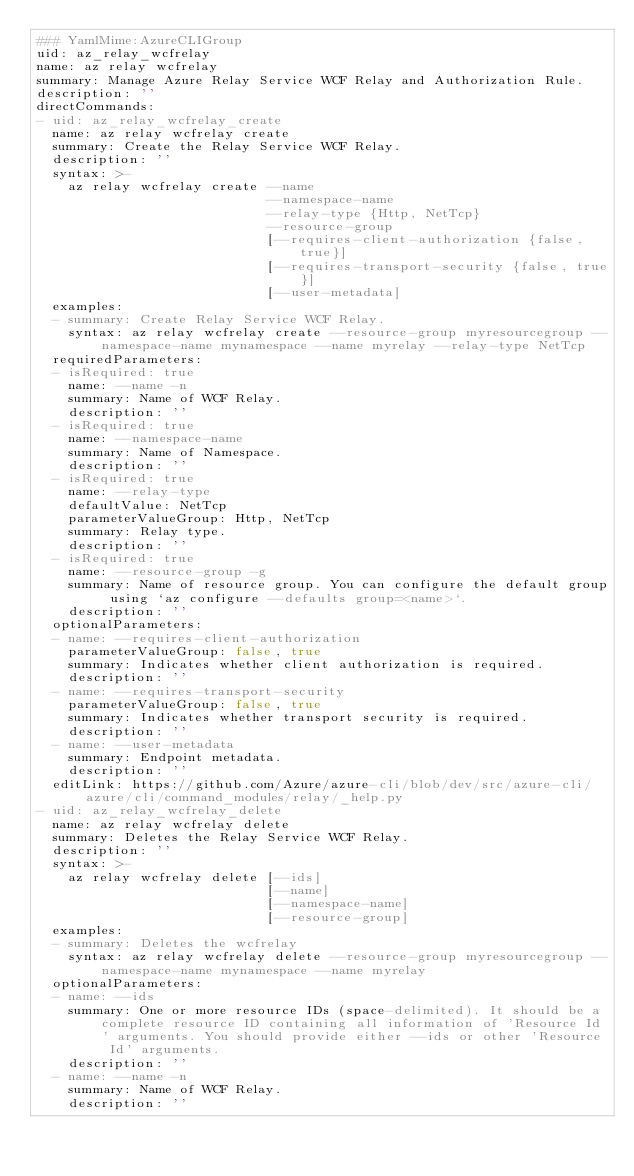Convert code to text. <code><loc_0><loc_0><loc_500><loc_500><_YAML_>### YamlMime:AzureCLIGroup
uid: az_relay_wcfrelay
name: az relay wcfrelay
summary: Manage Azure Relay Service WCF Relay and Authorization Rule.
description: ''
directCommands:
- uid: az_relay_wcfrelay_create
  name: az relay wcfrelay create
  summary: Create the Relay Service WCF Relay.
  description: ''
  syntax: >-
    az relay wcfrelay create --name
                             --namespace-name
                             --relay-type {Http, NetTcp}
                             --resource-group
                             [--requires-client-authorization {false, true}]
                             [--requires-transport-security {false, true}]
                             [--user-metadata]
  examples:
  - summary: Create Relay Service WCF Relay.
    syntax: az relay wcfrelay create --resource-group myresourcegroup --namespace-name mynamespace --name myrelay --relay-type NetTcp
  requiredParameters:
  - isRequired: true
    name: --name -n
    summary: Name of WCF Relay.
    description: ''
  - isRequired: true
    name: --namespace-name
    summary: Name of Namespace.
    description: ''
  - isRequired: true
    name: --relay-type
    defaultValue: NetTcp
    parameterValueGroup: Http, NetTcp
    summary: Relay type.
    description: ''
  - isRequired: true
    name: --resource-group -g
    summary: Name of resource group. You can configure the default group using `az configure --defaults group=<name>`.
    description: ''
  optionalParameters:
  - name: --requires-client-authorization
    parameterValueGroup: false, true
    summary: Indicates whether client authorization is required.
    description: ''
  - name: --requires-transport-security
    parameterValueGroup: false, true
    summary: Indicates whether transport security is required.
    description: ''
  - name: --user-metadata
    summary: Endpoint metadata.
    description: ''
  editLink: https://github.com/Azure/azure-cli/blob/dev/src/azure-cli/azure/cli/command_modules/relay/_help.py
- uid: az_relay_wcfrelay_delete
  name: az relay wcfrelay delete
  summary: Deletes the Relay Service WCF Relay.
  description: ''
  syntax: >-
    az relay wcfrelay delete [--ids]
                             [--name]
                             [--namespace-name]
                             [--resource-group]
  examples:
  - summary: Deletes the wcfrelay
    syntax: az relay wcfrelay delete --resource-group myresourcegroup --namespace-name mynamespace --name myrelay
  optionalParameters:
  - name: --ids
    summary: One or more resource IDs (space-delimited). It should be a complete resource ID containing all information of 'Resource Id' arguments. You should provide either --ids or other 'Resource Id' arguments.
    description: ''
  - name: --name -n
    summary: Name of WCF Relay.
    description: ''</code> 